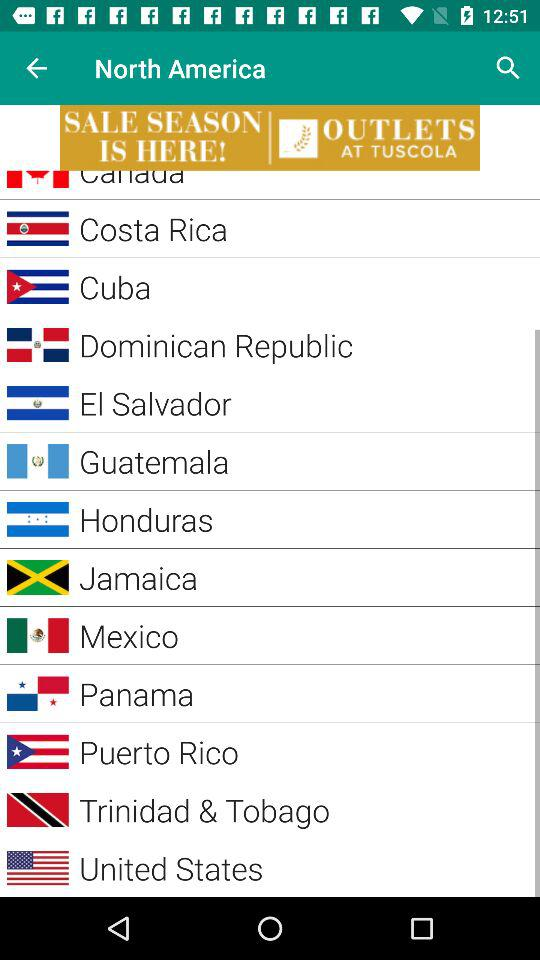How many countries are in the North America region?
Answer the question using a single word or phrase. 13 